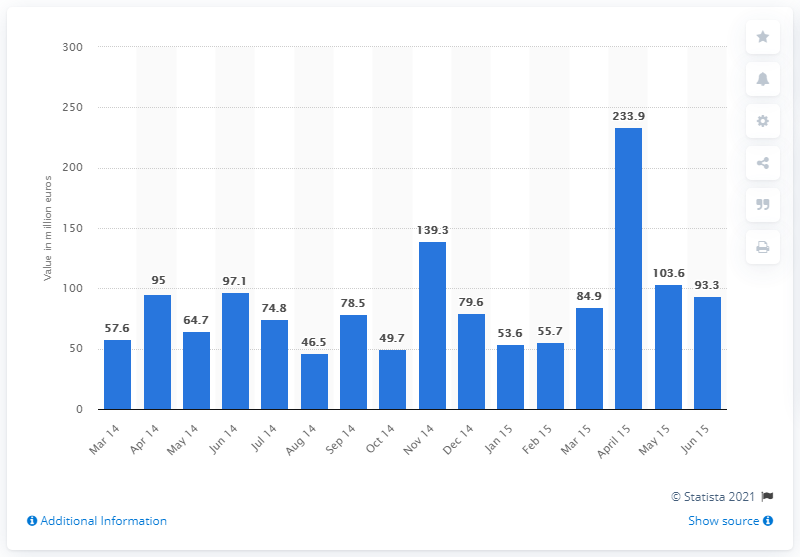Identify some key points in this picture. In June 2015, the value of M&A deals in Europe was 93.3. 